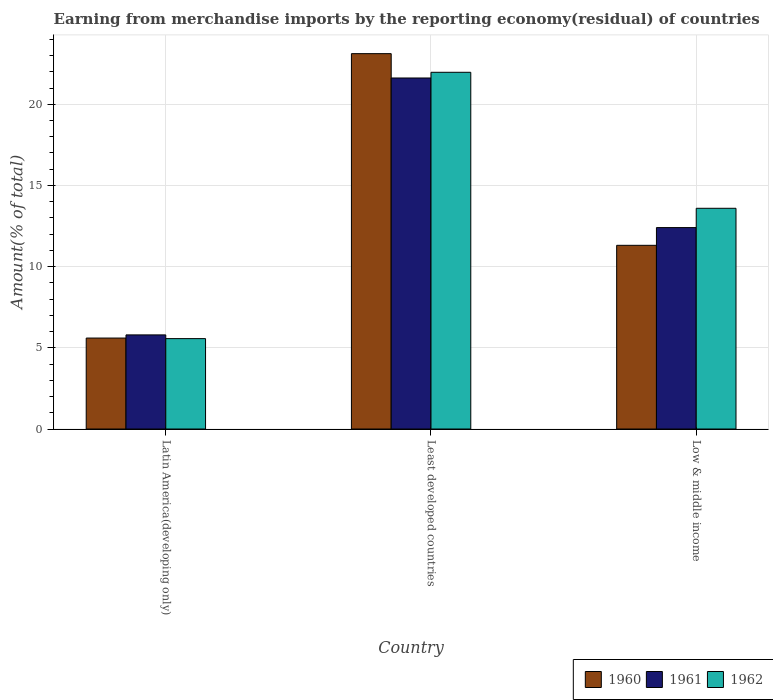How many different coloured bars are there?
Provide a succinct answer. 3. What is the label of the 2nd group of bars from the left?
Provide a short and direct response. Least developed countries. What is the percentage of amount earned from merchandise imports in 1962 in Least developed countries?
Provide a succinct answer. 21.97. Across all countries, what is the maximum percentage of amount earned from merchandise imports in 1961?
Keep it short and to the point. 21.62. Across all countries, what is the minimum percentage of amount earned from merchandise imports in 1962?
Make the answer very short. 5.57. In which country was the percentage of amount earned from merchandise imports in 1962 maximum?
Offer a terse response. Least developed countries. In which country was the percentage of amount earned from merchandise imports in 1962 minimum?
Provide a short and direct response. Latin America(developing only). What is the total percentage of amount earned from merchandise imports in 1962 in the graph?
Make the answer very short. 41.13. What is the difference between the percentage of amount earned from merchandise imports in 1962 in Latin America(developing only) and that in Least developed countries?
Provide a succinct answer. -16.4. What is the difference between the percentage of amount earned from merchandise imports in 1962 in Low & middle income and the percentage of amount earned from merchandise imports in 1961 in Least developed countries?
Give a very brief answer. -8.02. What is the average percentage of amount earned from merchandise imports in 1960 per country?
Provide a short and direct response. 13.35. What is the difference between the percentage of amount earned from merchandise imports of/in 1961 and percentage of amount earned from merchandise imports of/in 1962 in Least developed countries?
Your answer should be very brief. -0.35. In how many countries, is the percentage of amount earned from merchandise imports in 1962 greater than 21 %?
Provide a succinct answer. 1. What is the ratio of the percentage of amount earned from merchandise imports in 1960 in Latin America(developing only) to that in Least developed countries?
Your response must be concise. 0.24. What is the difference between the highest and the second highest percentage of amount earned from merchandise imports in 1960?
Offer a very short reply. 5.71. What is the difference between the highest and the lowest percentage of amount earned from merchandise imports in 1960?
Offer a terse response. 17.52. Is the sum of the percentage of amount earned from merchandise imports in 1960 in Least developed countries and Low & middle income greater than the maximum percentage of amount earned from merchandise imports in 1961 across all countries?
Keep it short and to the point. Yes. How many bars are there?
Your response must be concise. 9. How many countries are there in the graph?
Provide a short and direct response. 3. Are the values on the major ticks of Y-axis written in scientific E-notation?
Provide a succinct answer. No. Does the graph contain grids?
Make the answer very short. Yes. How are the legend labels stacked?
Offer a terse response. Horizontal. What is the title of the graph?
Offer a terse response. Earning from merchandise imports by the reporting economy(residual) of countries. Does "1962" appear as one of the legend labels in the graph?
Offer a terse response. Yes. What is the label or title of the Y-axis?
Offer a very short reply. Amount(% of total). What is the Amount(% of total) in 1960 in Latin America(developing only)?
Make the answer very short. 5.6. What is the Amount(% of total) of 1961 in Latin America(developing only)?
Provide a short and direct response. 5.8. What is the Amount(% of total) of 1962 in Latin America(developing only)?
Your response must be concise. 5.57. What is the Amount(% of total) in 1960 in Least developed countries?
Offer a terse response. 23.12. What is the Amount(% of total) in 1961 in Least developed countries?
Your response must be concise. 21.62. What is the Amount(% of total) in 1962 in Least developed countries?
Your answer should be compact. 21.97. What is the Amount(% of total) of 1960 in Low & middle income?
Your answer should be very brief. 11.31. What is the Amount(% of total) of 1961 in Low & middle income?
Provide a succinct answer. 12.41. What is the Amount(% of total) in 1962 in Low & middle income?
Your response must be concise. 13.59. Across all countries, what is the maximum Amount(% of total) in 1960?
Provide a short and direct response. 23.12. Across all countries, what is the maximum Amount(% of total) of 1961?
Offer a terse response. 21.62. Across all countries, what is the maximum Amount(% of total) in 1962?
Your answer should be compact. 21.97. Across all countries, what is the minimum Amount(% of total) of 1960?
Provide a succinct answer. 5.6. Across all countries, what is the minimum Amount(% of total) of 1961?
Your answer should be compact. 5.8. Across all countries, what is the minimum Amount(% of total) of 1962?
Provide a short and direct response. 5.57. What is the total Amount(% of total) of 1960 in the graph?
Provide a short and direct response. 40.04. What is the total Amount(% of total) of 1961 in the graph?
Offer a terse response. 39.82. What is the total Amount(% of total) in 1962 in the graph?
Provide a succinct answer. 41.13. What is the difference between the Amount(% of total) of 1960 in Latin America(developing only) and that in Least developed countries?
Provide a succinct answer. -17.52. What is the difference between the Amount(% of total) in 1961 in Latin America(developing only) and that in Least developed countries?
Provide a succinct answer. -15.82. What is the difference between the Amount(% of total) in 1962 in Latin America(developing only) and that in Least developed countries?
Your answer should be very brief. -16.4. What is the difference between the Amount(% of total) of 1960 in Latin America(developing only) and that in Low & middle income?
Provide a short and direct response. -5.71. What is the difference between the Amount(% of total) in 1961 in Latin America(developing only) and that in Low & middle income?
Your response must be concise. -6.61. What is the difference between the Amount(% of total) in 1962 in Latin America(developing only) and that in Low & middle income?
Your response must be concise. -8.03. What is the difference between the Amount(% of total) in 1960 in Least developed countries and that in Low & middle income?
Provide a succinct answer. 11.81. What is the difference between the Amount(% of total) in 1961 in Least developed countries and that in Low & middle income?
Provide a succinct answer. 9.21. What is the difference between the Amount(% of total) in 1962 in Least developed countries and that in Low & middle income?
Offer a very short reply. 8.38. What is the difference between the Amount(% of total) of 1960 in Latin America(developing only) and the Amount(% of total) of 1961 in Least developed countries?
Offer a terse response. -16.02. What is the difference between the Amount(% of total) of 1960 in Latin America(developing only) and the Amount(% of total) of 1962 in Least developed countries?
Offer a terse response. -16.37. What is the difference between the Amount(% of total) of 1961 in Latin America(developing only) and the Amount(% of total) of 1962 in Least developed countries?
Make the answer very short. -16.17. What is the difference between the Amount(% of total) in 1960 in Latin America(developing only) and the Amount(% of total) in 1961 in Low & middle income?
Your answer should be very brief. -6.8. What is the difference between the Amount(% of total) in 1960 in Latin America(developing only) and the Amount(% of total) in 1962 in Low & middle income?
Your answer should be very brief. -7.99. What is the difference between the Amount(% of total) in 1961 in Latin America(developing only) and the Amount(% of total) in 1962 in Low & middle income?
Provide a short and direct response. -7.8. What is the difference between the Amount(% of total) in 1960 in Least developed countries and the Amount(% of total) in 1961 in Low & middle income?
Offer a terse response. 10.71. What is the difference between the Amount(% of total) in 1960 in Least developed countries and the Amount(% of total) in 1962 in Low & middle income?
Your answer should be compact. 9.52. What is the difference between the Amount(% of total) in 1961 in Least developed countries and the Amount(% of total) in 1962 in Low & middle income?
Keep it short and to the point. 8.02. What is the average Amount(% of total) of 1960 per country?
Give a very brief answer. 13.35. What is the average Amount(% of total) of 1961 per country?
Provide a succinct answer. 13.27. What is the average Amount(% of total) of 1962 per country?
Offer a very short reply. 13.71. What is the difference between the Amount(% of total) in 1960 and Amount(% of total) in 1961 in Latin America(developing only)?
Your answer should be compact. -0.19. What is the difference between the Amount(% of total) of 1960 and Amount(% of total) of 1962 in Latin America(developing only)?
Provide a succinct answer. 0.03. What is the difference between the Amount(% of total) of 1961 and Amount(% of total) of 1962 in Latin America(developing only)?
Give a very brief answer. 0.23. What is the difference between the Amount(% of total) in 1960 and Amount(% of total) in 1961 in Least developed countries?
Offer a very short reply. 1.5. What is the difference between the Amount(% of total) in 1960 and Amount(% of total) in 1962 in Least developed countries?
Provide a short and direct response. 1.15. What is the difference between the Amount(% of total) of 1961 and Amount(% of total) of 1962 in Least developed countries?
Make the answer very short. -0.35. What is the difference between the Amount(% of total) in 1960 and Amount(% of total) in 1961 in Low & middle income?
Offer a terse response. -1.09. What is the difference between the Amount(% of total) in 1960 and Amount(% of total) in 1962 in Low & middle income?
Your response must be concise. -2.28. What is the difference between the Amount(% of total) of 1961 and Amount(% of total) of 1962 in Low & middle income?
Your answer should be very brief. -1.19. What is the ratio of the Amount(% of total) of 1960 in Latin America(developing only) to that in Least developed countries?
Your response must be concise. 0.24. What is the ratio of the Amount(% of total) of 1961 in Latin America(developing only) to that in Least developed countries?
Your answer should be very brief. 0.27. What is the ratio of the Amount(% of total) in 1962 in Latin America(developing only) to that in Least developed countries?
Give a very brief answer. 0.25. What is the ratio of the Amount(% of total) in 1960 in Latin America(developing only) to that in Low & middle income?
Ensure brevity in your answer.  0.5. What is the ratio of the Amount(% of total) of 1961 in Latin America(developing only) to that in Low & middle income?
Your answer should be very brief. 0.47. What is the ratio of the Amount(% of total) of 1962 in Latin America(developing only) to that in Low & middle income?
Offer a terse response. 0.41. What is the ratio of the Amount(% of total) in 1960 in Least developed countries to that in Low & middle income?
Offer a terse response. 2.04. What is the ratio of the Amount(% of total) in 1961 in Least developed countries to that in Low & middle income?
Offer a terse response. 1.74. What is the ratio of the Amount(% of total) of 1962 in Least developed countries to that in Low & middle income?
Offer a very short reply. 1.62. What is the difference between the highest and the second highest Amount(% of total) of 1960?
Your answer should be compact. 11.81. What is the difference between the highest and the second highest Amount(% of total) of 1961?
Your answer should be very brief. 9.21. What is the difference between the highest and the second highest Amount(% of total) of 1962?
Keep it short and to the point. 8.38. What is the difference between the highest and the lowest Amount(% of total) of 1960?
Offer a very short reply. 17.52. What is the difference between the highest and the lowest Amount(% of total) in 1961?
Give a very brief answer. 15.82. What is the difference between the highest and the lowest Amount(% of total) in 1962?
Provide a succinct answer. 16.4. 